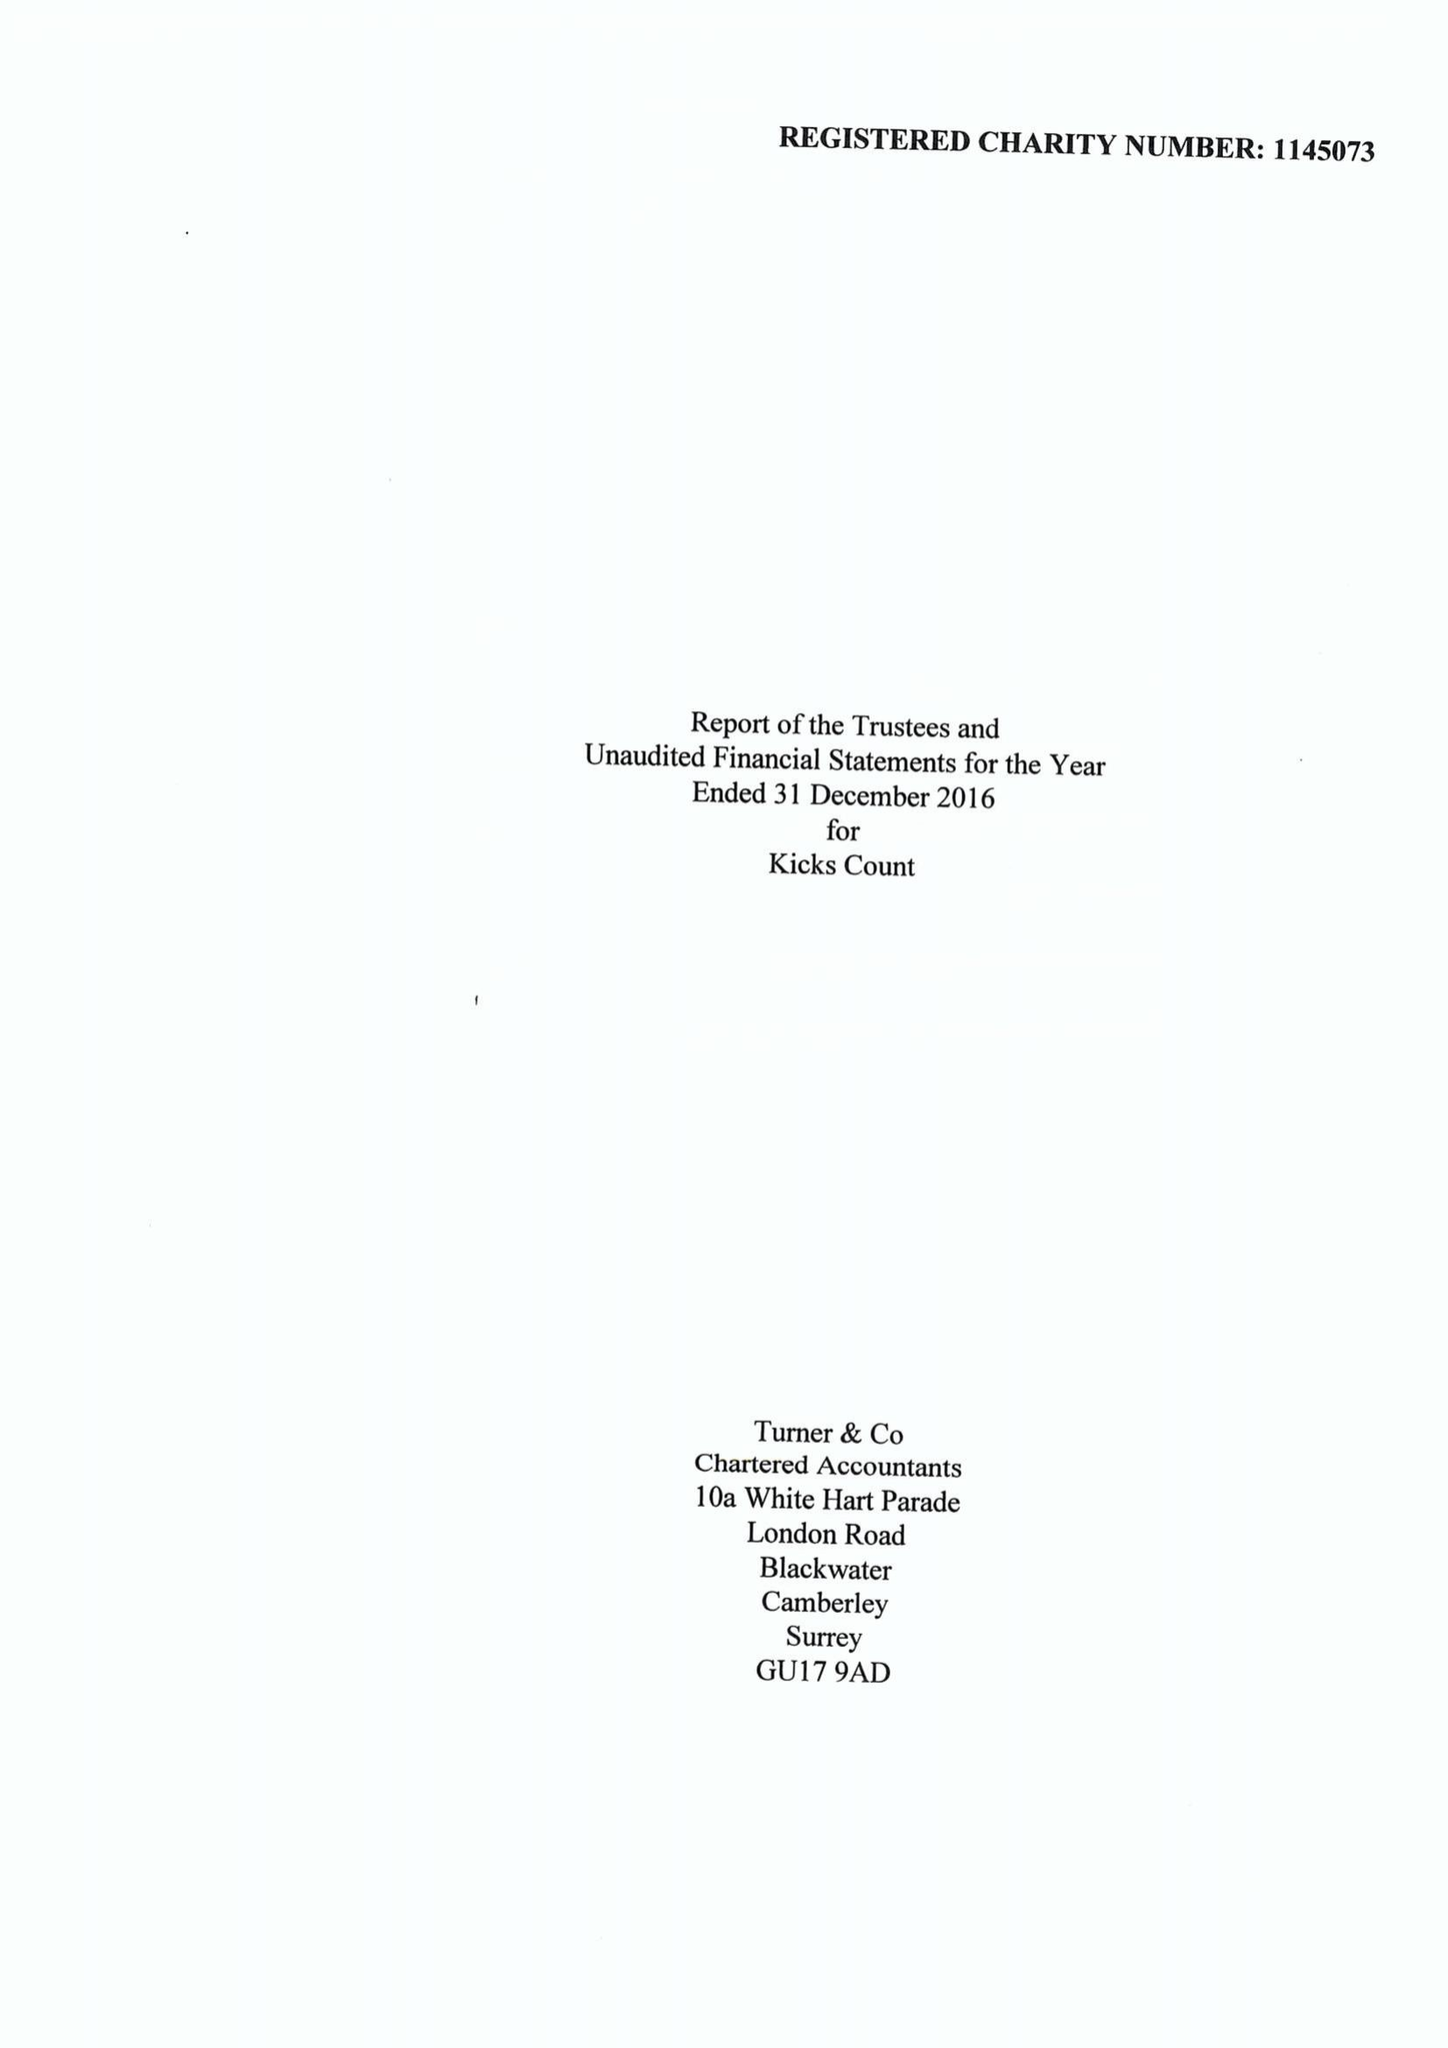What is the value for the income_annually_in_british_pounds?
Answer the question using a single word or phrase. 165726.00 